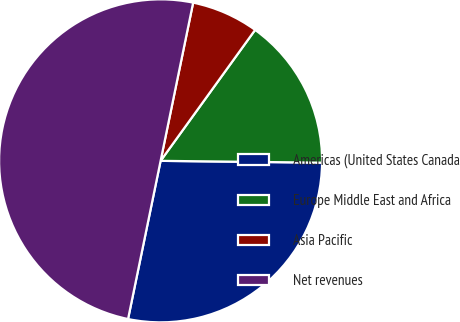<chart> <loc_0><loc_0><loc_500><loc_500><pie_chart><fcel>Americas (United States Canada<fcel>Europe Middle East and Africa<fcel>Asia Pacific<fcel>Net revenues<nl><fcel>28.05%<fcel>15.23%<fcel>6.72%<fcel>50.0%<nl></chart> 